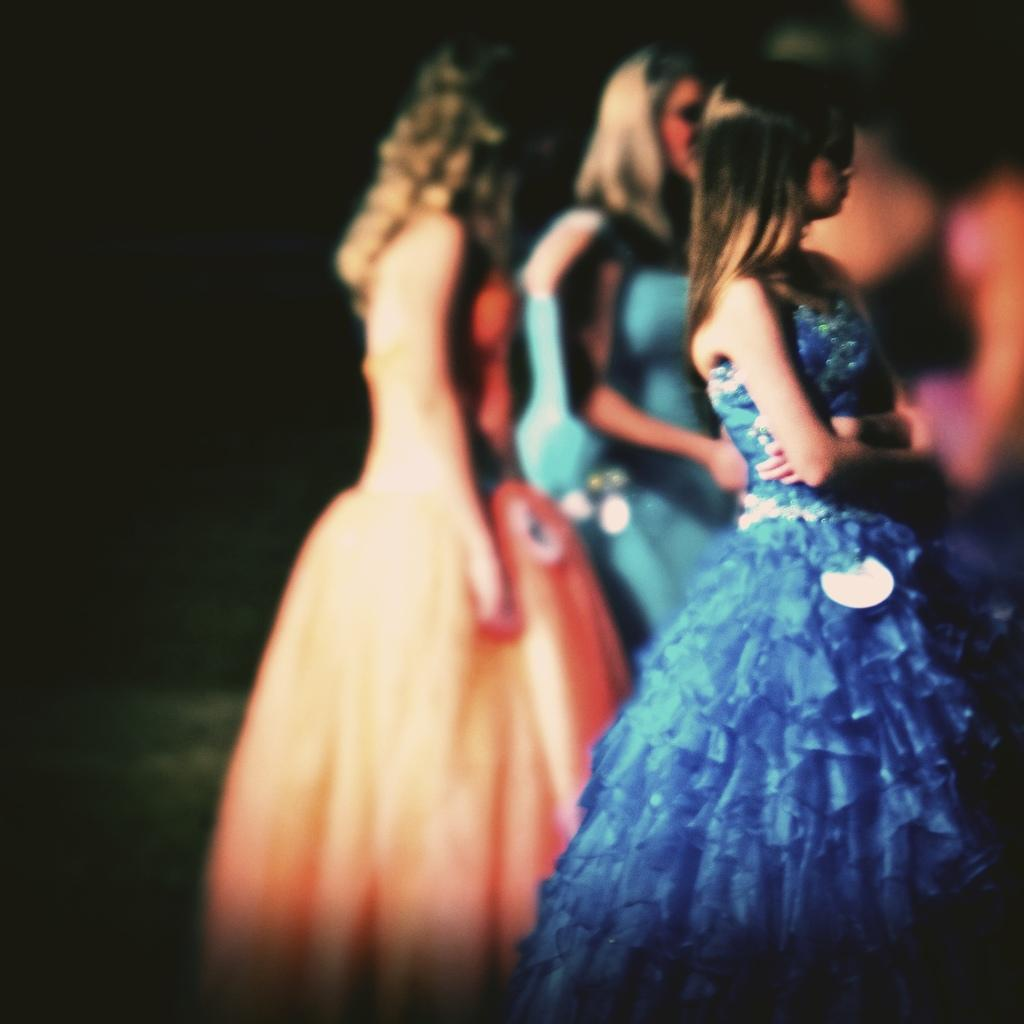What is happening in the image? There are people standing in the image. Can you describe the background of the image? The background of the image is dark. Are there any planes visible in the cemetery in the image? There is no cemetery or planes present in the image; it only shows people standing with a dark background. 